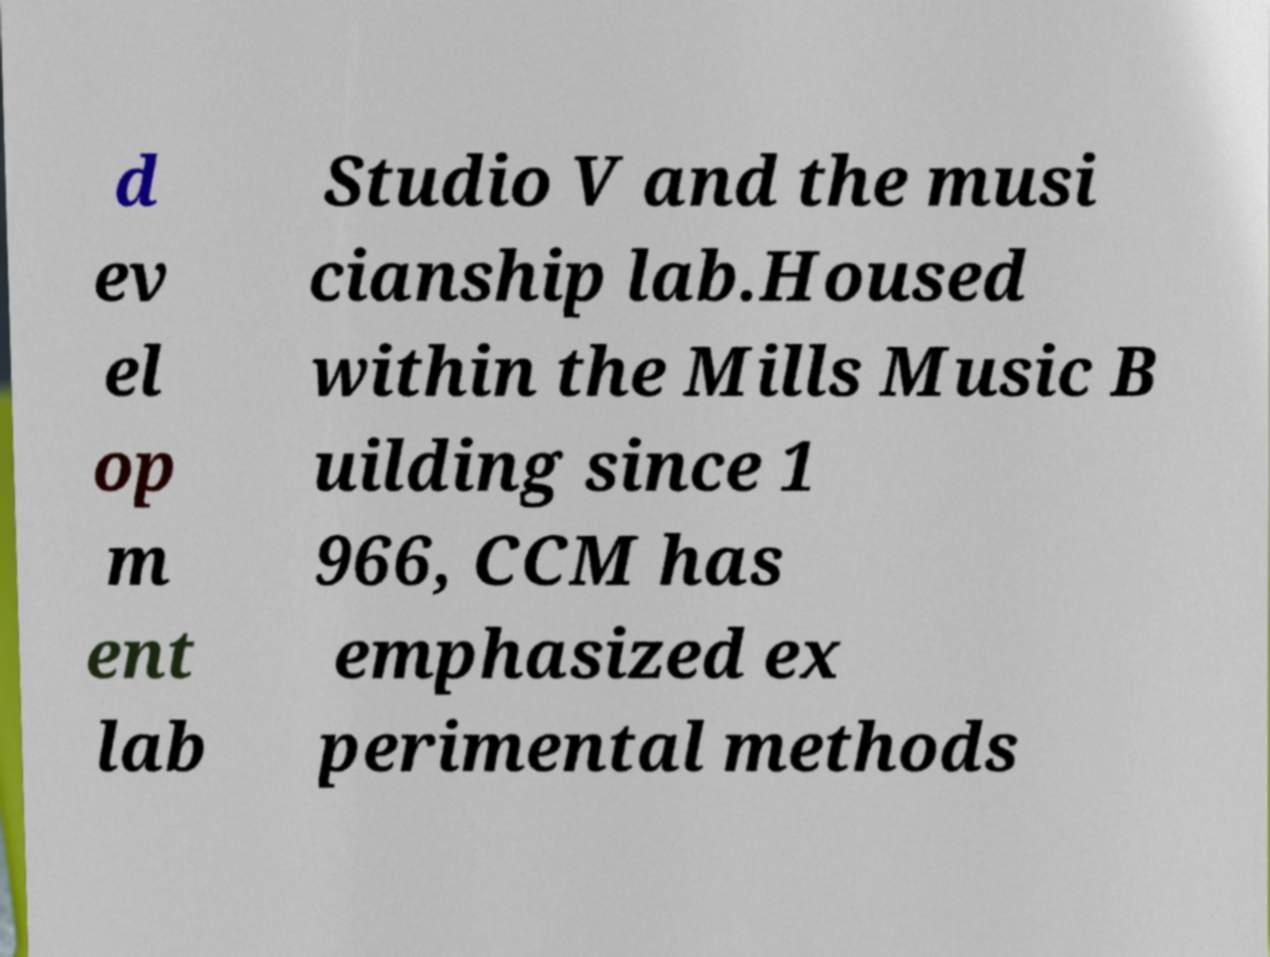Can you read and provide the text displayed in the image?This photo seems to have some interesting text. Can you extract and type it out for me? d ev el op m ent lab Studio V and the musi cianship lab.Housed within the Mills Music B uilding since 1 966, CCM has emphasized ex perimental methods 